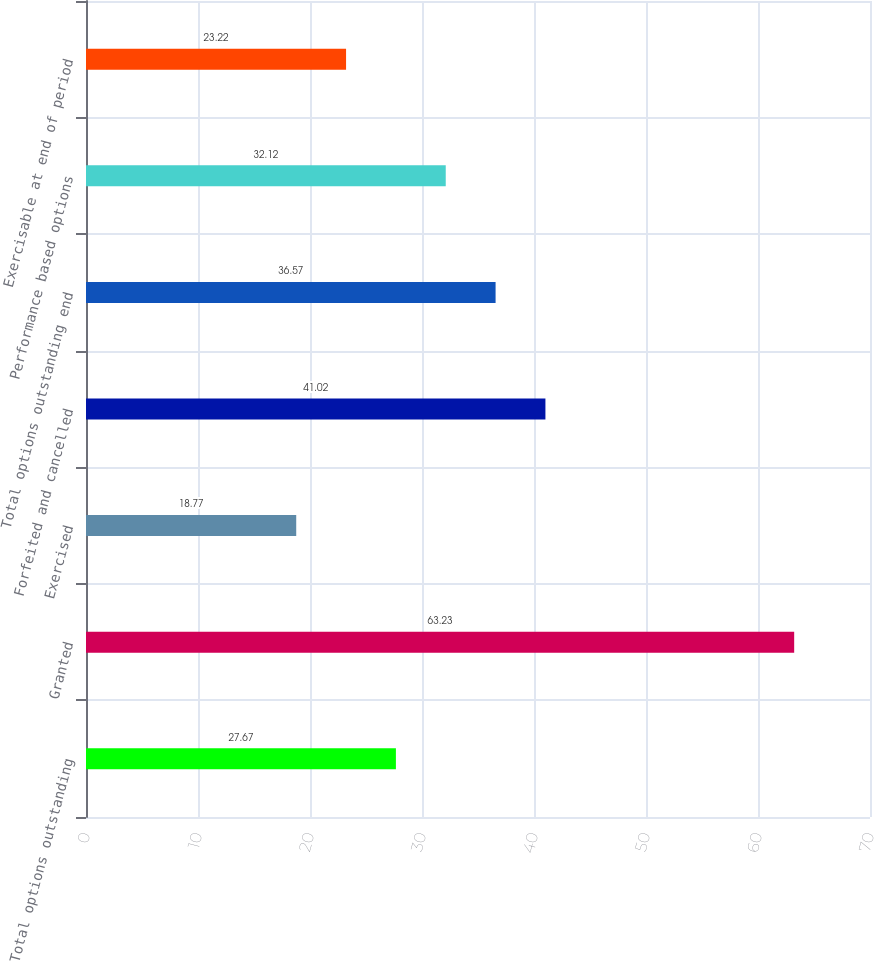Convert chart to OTSL. <chart><loc_0><loc_0><loc_500><loc_500><bar_chart><fcel>Total options outstanding<fcel>Granted<fcel>Exercised<fcel>Forfeited and cancelled<fcel>Total options outstanding end<fcel>Performance based options<fcel>Exercisable at end of period<nl><fcel>27.67<fcel>63.23<fcel>18.77<fcel>41.02<fcel>36.57<fcel>32.12<fcel>23.22<nl></chart> 